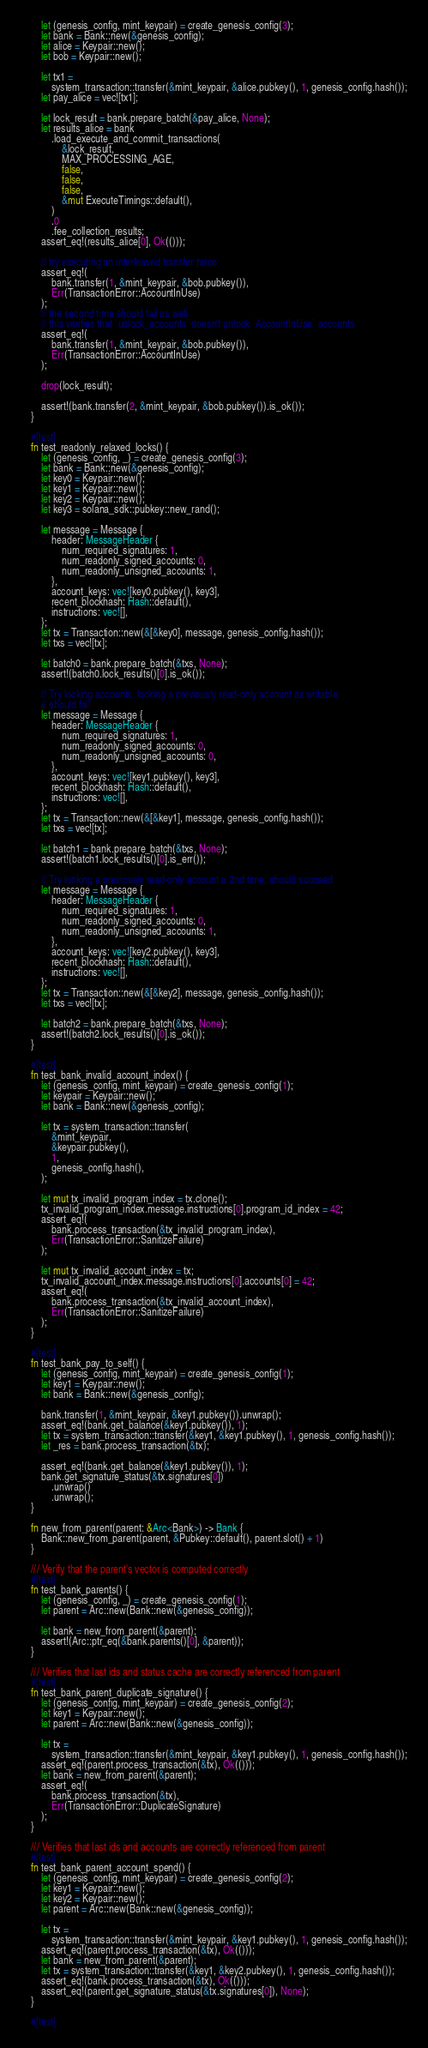<code> <loc_0><loc_0><loc_500><loc_500><_Rust_>        let (genesis_config, mint_keypair) = create_genesis_config(3);
        let bank = Bank::new(&genesis_config);
        let alice = Keypair::new();
        let bob = Keypair::new();

        let tx1 =
            system_transaction::transfer(&mint_keypair, &alice.pubkey(), 1, genesis_config.hash());
        let pay_alice = vec![tx1];

        let lock_result = bank.prepare_batch(&pay_alice, None);
        let results_alice = bank
            .load_execute_and_commit_transactions(
                &lock_result,
                MAX_PROCESSING_AGE,
                false,
                false,
                false,
                &mut ExecuteTimings::default(),
            )
            .0
            .fee_collection_results;
        assert_eq!(results_alice[0], Ok(()));

        // try executing an interleaved transfer twice
        assert_eq!(
            bank.transfer(1, &mint_keypair, &bob.pubkey()),
            Err(TransactionError::AccountInUse)
        );
        // the second time should fail as well
        // this verifies that `unlock_accounts` doesn't unlock `AccountInUse` accounts
        assert_eq!(
            bank.transfer(1, &mint_keypair, &bob.pubkey()),
            Err(TransactionError::AccountInUse)
        );

        drop(lock_result);

        assert!(bank.transfer(2, &mint_keypair, &bob.pubkey()).is_ok());
    }

    #[test]
    fn test_readonly_relaxed_locks() {
        let (genesis_config, _) = create_genesis_config(3);
        let bank = Bank::new(&genesis_config);
        let key0 = Keypair::new();
        let key1 = Keypair::new();
        let key2 = Keypair::new();
        let key3 = solana_sdk::pubkey::new_rand();

        let message = Message {
            header: MessageHeader {
                num_required_signatures: 1,
                num_readonly_signed_accounts: 0,
                num_readonly_unsigned_accounts: 1,
            },
            account_keys: vec![key0.pubkey(), key3],
            recent_blockhash: Hash::default(),
            instructions: vec![],
        };
        let tx = Transaction::new(&[&key0], message, genesis_config.hash());
        let txs = vec![tx];

        let batch0 = bank.prepare_batch(&txs, None);
        assert!(batch0.lock_results()[0].is_ok());

        // Try locking accounts, locking a previously read-only account as writable
        // should fail
        let message = Message {
            header: MessageHeader {
                num_required_signatures: 1,
                num_readonly_signed_accounts: 0,
                num_readonly_unsigned_accounts: 0,
            },
            account_keys: vec![key1.pubkey(), key3],
            recent_blockhash: Hash::default(),
            instructions: vec![],
        };
        let tx = Transaction::new(&[&key1], message, genesis_config.hash());
        let txs = vec![tx];

        let batch1 = bank.prepare_batch(&txs, None);
        assert!(batch1.lock_results()[0].is_err());

        // Try locking a previously read-only account a 2nd time; should succeed
        let message = Message {
            header: MessageHeader {
                num_required_signatures: 1,
                num_readonly_signed_accounts: 0,
                num_readonly_unsigned_accounts: 1,
            },
            account_keys: vec![key2.pubkey(), key3],
            recent_blockhash: Hash::default(),
            instructions: vec![],
        };
        let tx = Transaction::new(&[&key2], message, genesis_config.hash());
        let txs = vec![tx];

        let batch2 = bank.prepare_batch(&txs, None);
        assert!(batch2.lock_results()[0].is_ok());
    }

    #[test]
    fn test_bank_invalid_account_index() {
        let (genesis_config, mint_keypair) = create_genesis_config(1);
        let keypair = Keypair::new();
        let bank = Bank::new(&genesis_config);

        let tx = system_transaction::transfer(
            &mint_keypair,
            &keypair.pubkey(),
            1,
            genesis_config.hash(),
        );

        let mut tx_invalid_program_index = tx.clone();
        tx_invalid_program_index.message.instructions[0].program_id_index = 42;
        assert_eq!(
            bank.process_transaction(&tx_invalid_program_index),
            Err(TransactionError::SanitizeFailure)
        );

        let mut tx_invalid_account_index = tx;
        tx_invalid_account_index.message.instructions[0].accounts[0] = 42;
        assert_eq!(
            bank.process_transaction(&tx_invalid_account_index),
            Err(TransactionError::SanitizeFailure)
        );
    }

    #[test]
    fn test_bank_pay_to_self() {
        let (genesis_config, mint_keypair) = create_genesis_config(1);
        let key1 = Keypair::new();
        let bank = Bank::new(&genesis_config);

        bank.transfer(1, &mint_keypair, &key1.pubkey()).unwrap();
        assert_eq!(bank.get_balance(&key1.pubkey()), 1);
        let tx = system_transaction::transfer(&key1, &key1.pubkey(), 1, genesis_config.hash());
        let _res = bank.process_transaction(&tx);

        assert_eq!(bank.get_balance(&key1.pubkey()), 1);
        bank.get_signature_status(&tx.signatures[0])
            .unwrap()
            .unwrap();
    }

    fn new_from_parent(parent: &Arc<Bank>) -> Bank {
        Bank::new_from_parent(parent, &Pubkey::default(), parent.slot() + 1)
    }

    /// Verify that the parent's vector is computed correctly
    #[test]
    fn test_bank_parents() {
        let (genesis_config, _) = create_genesis_config(1);
        let parent = Arc::new(Bank::new(&genesis_config));

        let bank = new_from_parent(&parent);
        assert!(Arc::ptr_eq(&bank.parents()[0], &parent));
    }

    /// Verifies that last ids and status cache are correctly referenced from parent
    #[test]
    fn test_bank_parent_duplicate_signature() {
        let (genesis_config, mint_keypair) = create_genesis_config(2);
        let key1 = Keypair::new();
        let parent = Arc::new(Bank::new(&genesis_config));

        let tx =
            system_transaction::transfer(&mint_keypair, &key1.pubkey(), 1, genesis_config.hash());
        assert_eq!(parent.process_transaction(&tx), Ok(()));
        let bank = new_from_parent(&parent);
        assert_eq!(
            bank.process_transaction(&tx),
            Err(TransactionError::DuplicateSignature)
        );
    }

    /// Verifies that last ids and accounts are correctly referenced from parent
    #[test]
    fn test_bank_parent_account_spend() {
        let (genesis_config, mint_keypair) = create_genesis_config(2);
        let key1 = Keypair::new();
        let key2 = Keypair::new();
        let parent = Arc::new(Bank::new(&genesis_config));

        let tx =
            system_transaction::transfer(&mint_keypair, &key1.pubkey(), 1, genesis_config.hash());
        assert_eq!(parent.process_transaction(&tx), Ok(()));
        let bank = new_from_parent(&parent);
        let tx = system_transaction::transfer(&key1, &key2.pubkey(), 1, genesis_config.hash());
        assert_eq!(bank.process_transaction(&tx), Ok(()));
        assert_eq!(parent.get_signature_status(&tx.signatures[0]), None);
    }

    #[test]</code> 